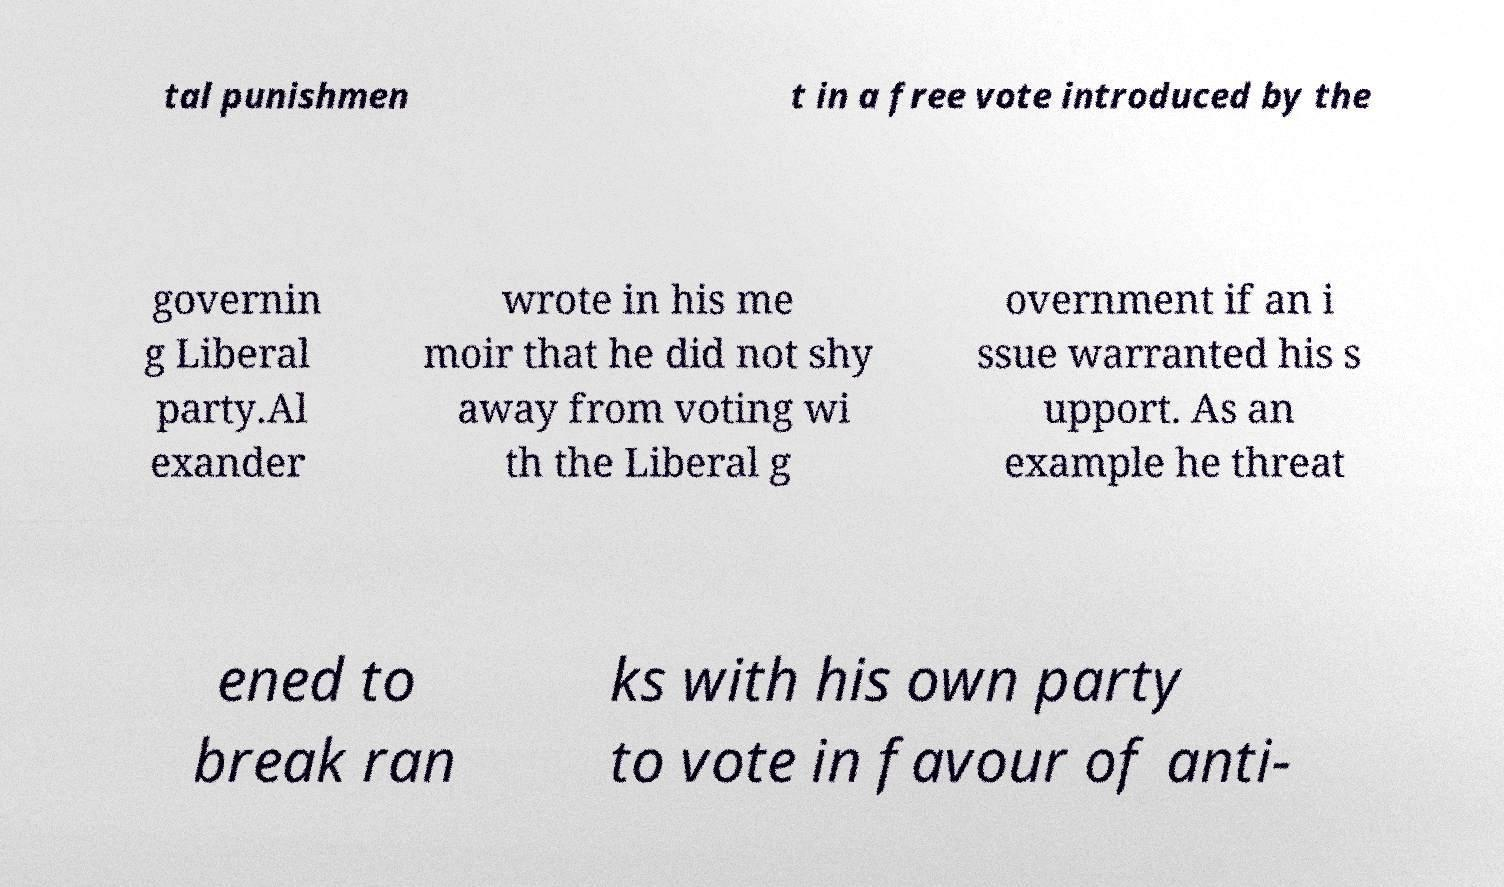There's text embedded in this image that I need extracted. Can you transcribe it verbatim? tal punishmen t in a free vote introduced by the governin g Liberal party.Al exander wrote in his me moir that he did not shy away from voting wi th the Liberal g overnment if an i ssue warranted his s upport. As an example he threat ened to break ran ks with his own party to vote in favour of anti- 